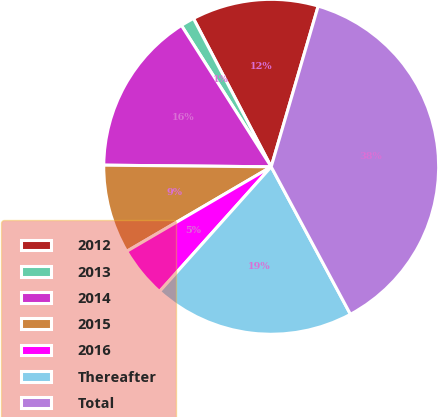Convert chart. <chart><loc_0><loc_0><loc_500><loc_500><pie_chart><fcel>2012<fcel>2013<fcel>2014<fcel>2015<fcel>2016<fcel>Thereafter<fcel>Total<nl><fcel>12.21%<fcel>1.32%<fcel>15.84%<fcel>8.58%<fcel>4.95%<fcel>19.47%<fcel>37.62%<nl></chart> 